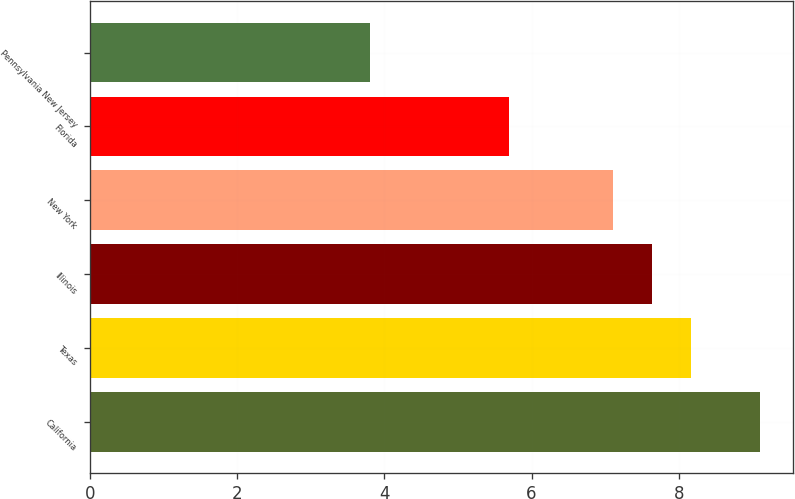Convert chart to OTSL. <chart><loc_0><loc_0><loc_500><loc_500><bar_chart><fcel>California<fcel>Texas<fcel>Illinois<fcel>New York<fcel>Florida<fcel>Pennsylvania New Jersey<nl><fcel>9.1<fcel>8.16<fcel>7.63<fcel>7.1<fcel>5.7<fcel>3.8<nl></chart> 